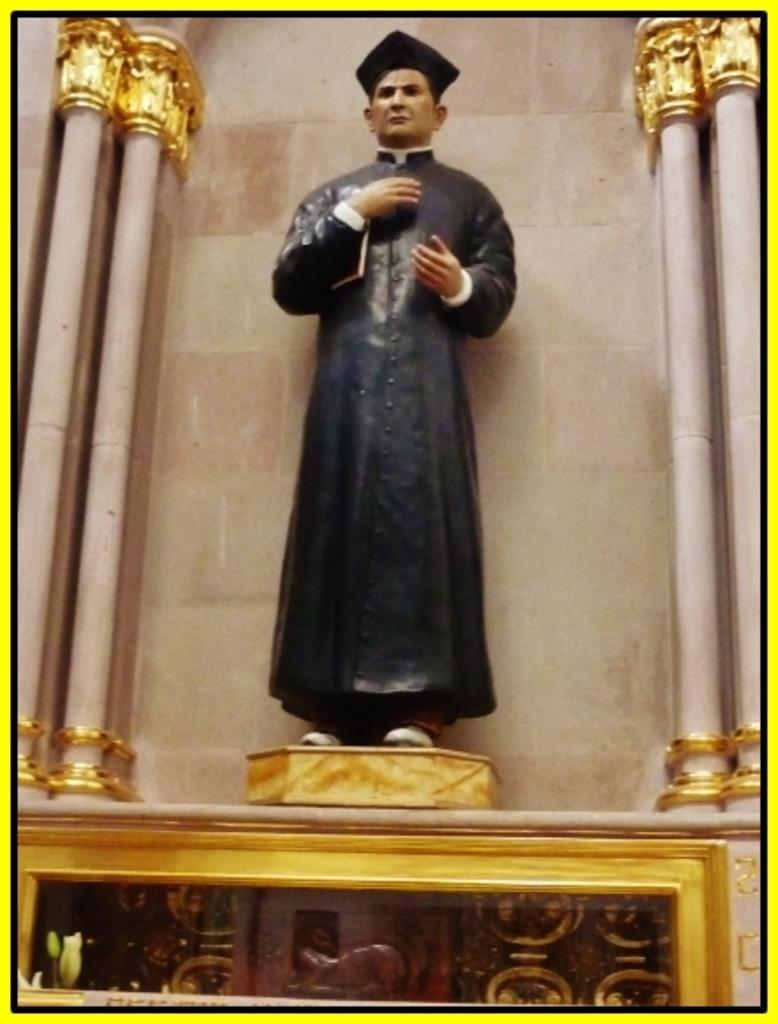Please provide a concise description of this image. In this picture we can see a statue and pillars on the right and left side. 